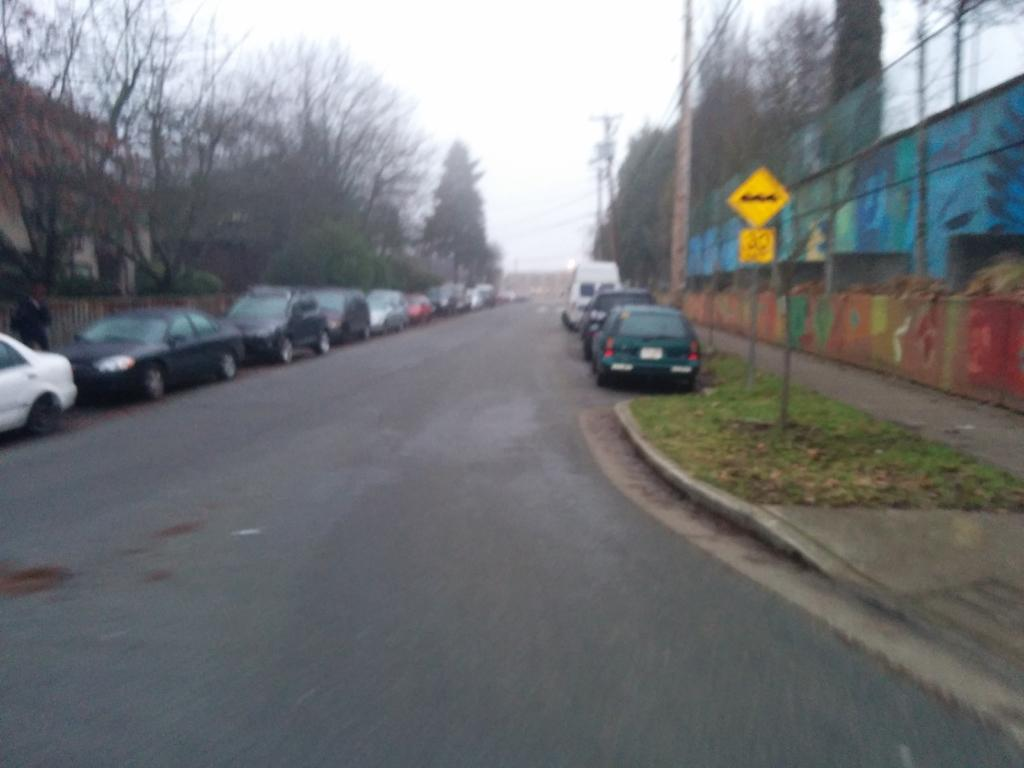What is happening on the road in the image? There are vehicles on the road in the image. What can be seen in the distance behind the vehicles? There are buildings, trees, poles, boards, and the sky visible in the background of the image. What type of scissors can be seen cutting the letters in the image? There are no scissors or letters present in the image. What key is used to unlock the door of the building in the image? There is no key or door visible in the image. 